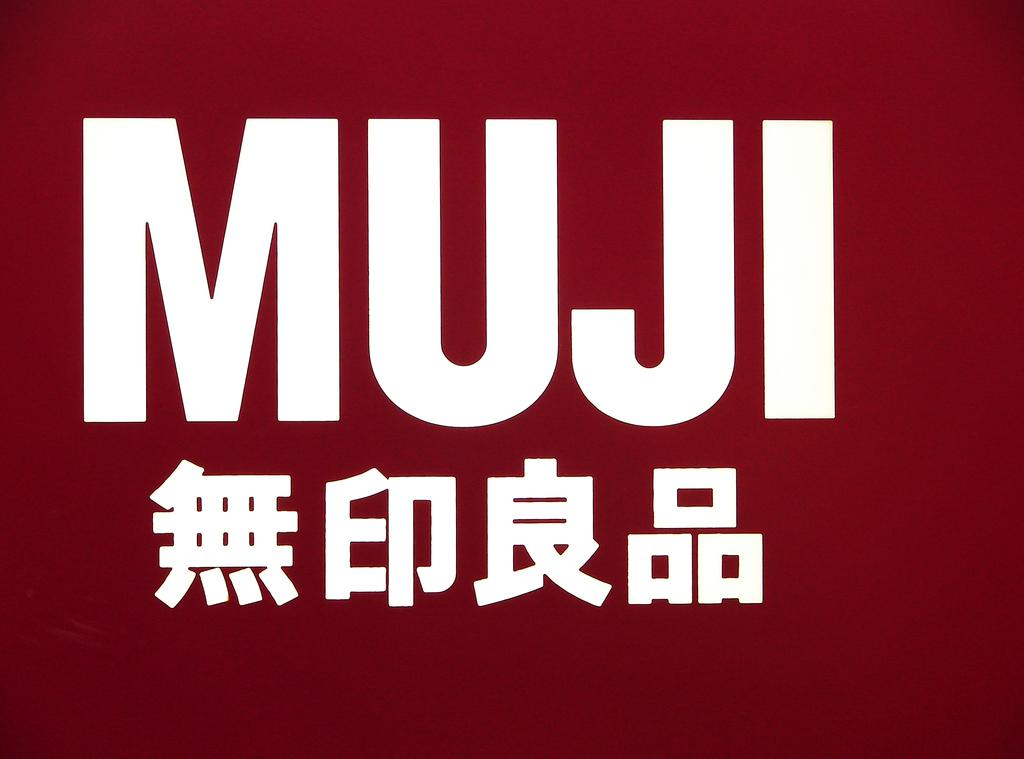<image>
Describe the image concisely. white writing MUJI on top of a red background with chinese symbols beneath it 